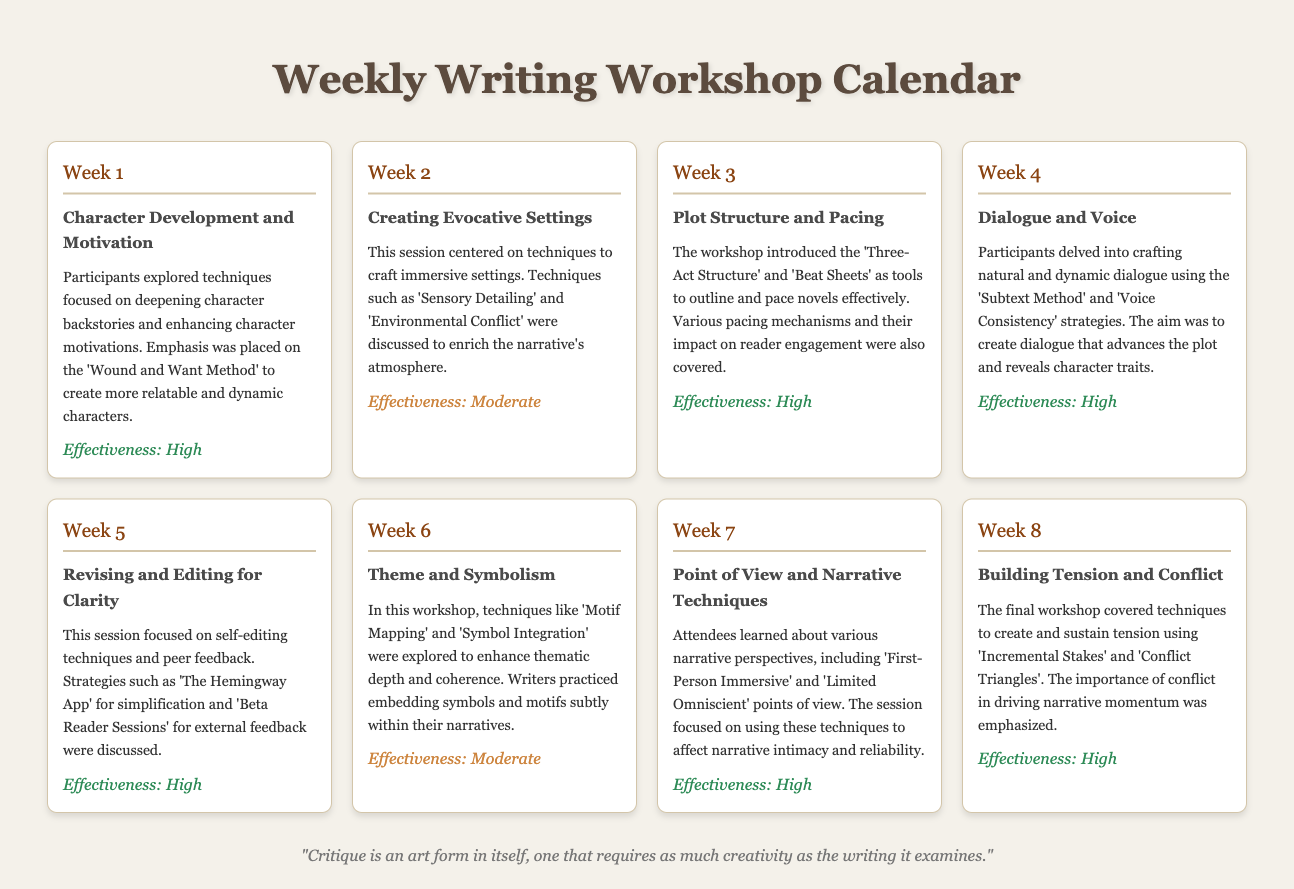What is the title of Week 3's workshop? The title of Week 3's workshop is specified as "Plot Structure and Pacing."
Answer: Plot Structure and Pacing What is the effectiveness rating for Week 2? The effectiveness rating provided for Week 2 is "Moderate."
Answer: Moderate How many workshops focus on character dialogue? The document details two workshops that focus on character dialogue, specifically Week 4 and discussions surrounding it.
Answer: Two Which method was emphasized in Week 1? The document highlights the "Wound and Want Method" as a key emphasis for character development in Week 1.
Answer: Wound and Want Method What narrative perspective was primarily discussed in Week 7? Week 7 focused on the "First-Person Immersive" narrative perspective.
Answer: First-Person Immersive What workshop technique was discussed in Week 6? The techniques discussed in Week 6 include "Motif Mapping" and "Symbol Integration."
Answer: Motif Mapping and Symbol Integration How many weeks have high effectiveness ratings? There are five weeks that have been rated as high effectiveness throughout the workshops.
Answer: Five What is the theme of Week 5's workshop? The theme of Week 5's workshop is centered around "Revising and Editing for Clarity."
Answer: Revising and Editing for Clarity What is the main focus of the final workshop? The final workshop's main focus is on building tension and conflict.
Answer: Building tension and conflict 